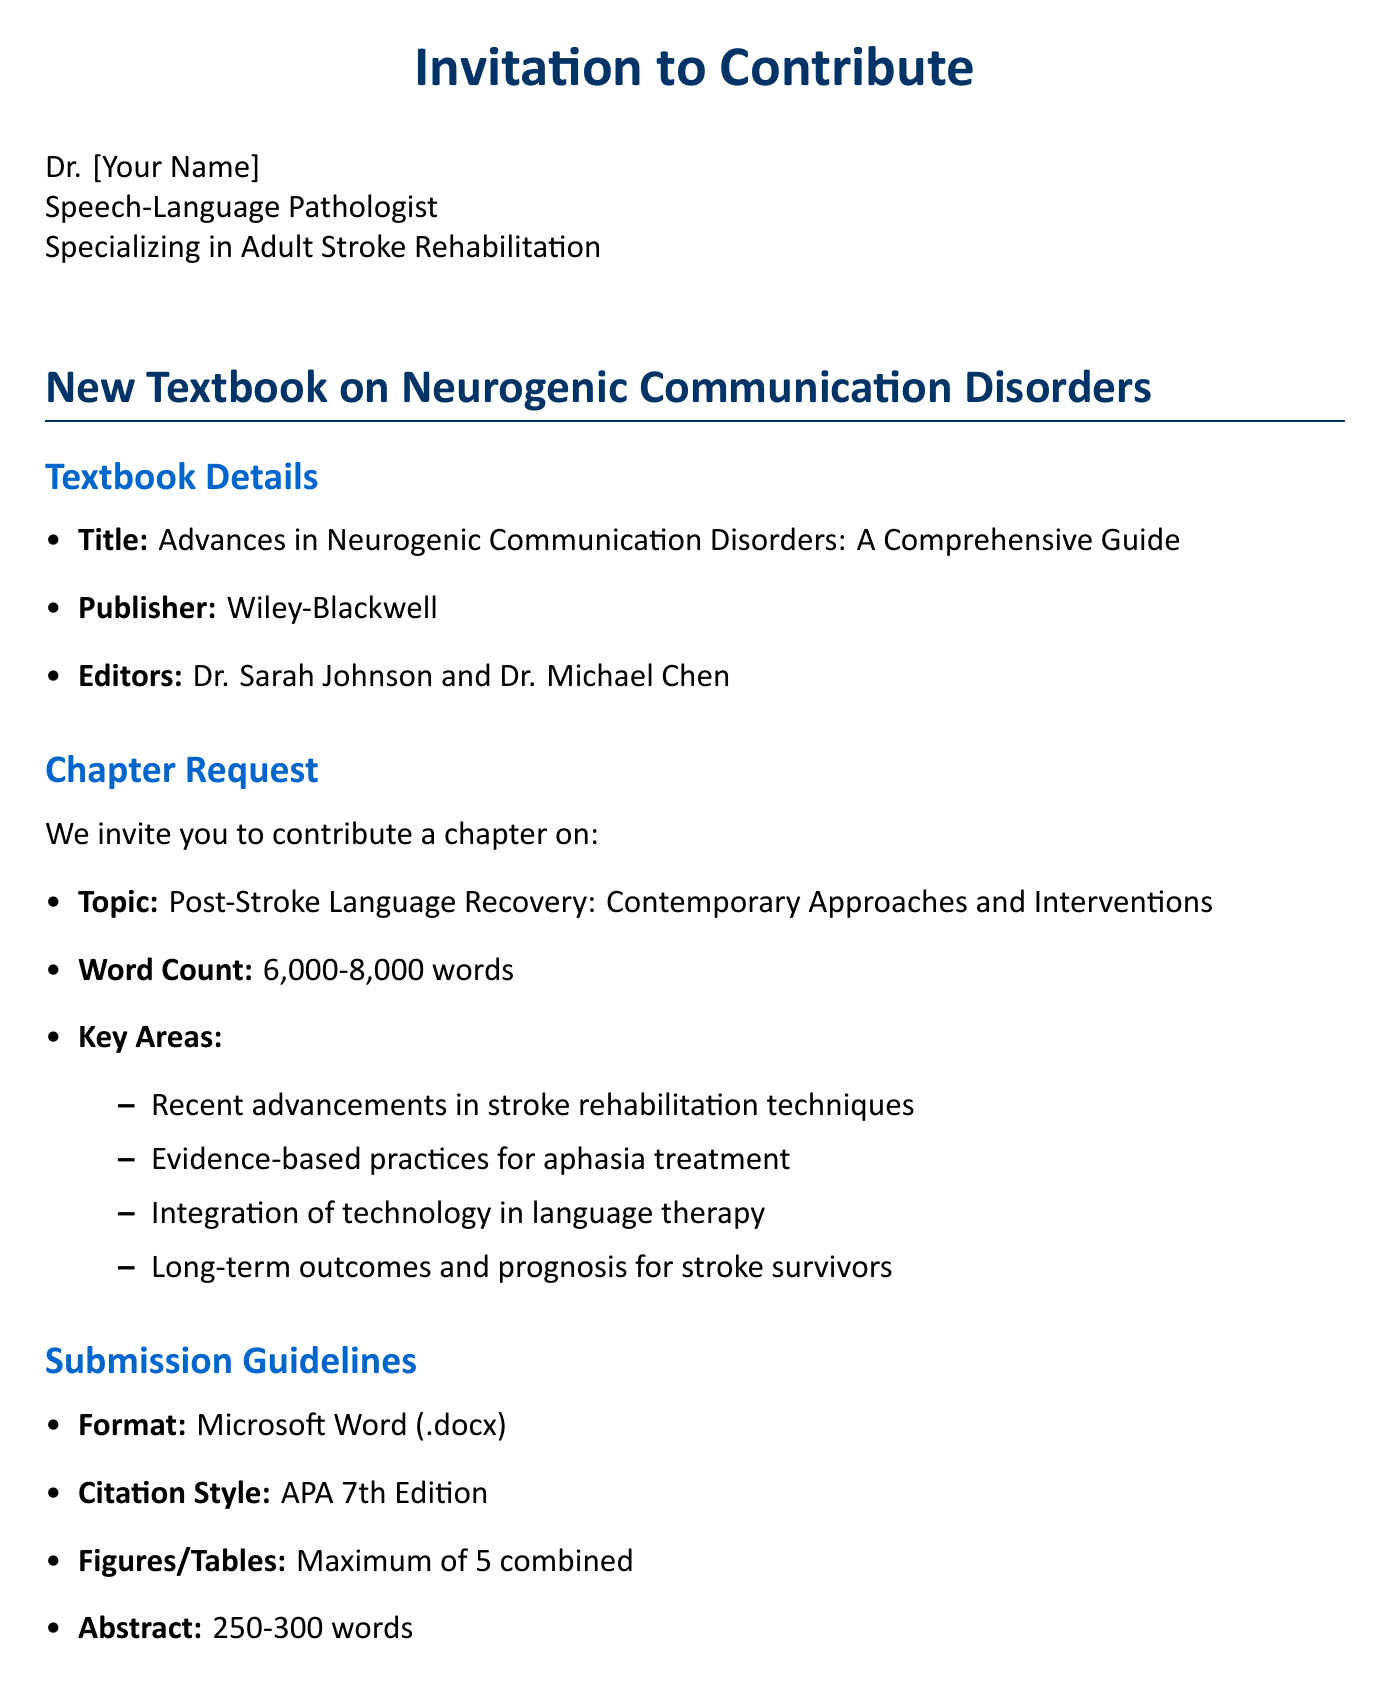What is the title of the textbook? The title of the textbook is provided in the document.
Answer: Advances in Neurogenic Communication Disorders: A Comprehensive Guide Who are the editors of the textbook? The document lists the editors of the textbook as part of the details section.
Answer: Dr. Sarah Johnson and Dr. Michael Chen What is the word count range for the chapter? The document specifies the required word count for the chapter in the chapter request section.
Answer: 6,000-8,000 words When is the abstract submission deadline? The abstract submission deadline is listed under important dates in the document.
Answer: September 15, 2023 What is one of the key areas to be covered in the chapter? The document outlines several key areas under chapter request that need to be addressed in the chapter.
Answer: Recent advancements in stroke rehabilitation techniques What format should the manuscript be submitted in? The submission guidelines section of the document specifies the required format for the manuscript.
Answer: Microsoft Word (.docx) When is the final manuscript due? The final manuscript due date is indicated in the important dates section of the document.
Answer: June 30, 2024 What citation style should be used in the manuscript? The document provides specific submission guidelines regarding citation style in the submission guidelines section.
Answer: APA 7th Edition What is the email contact for inquiries? The contact information section of the document lists the email for further inquiries.
Answer: neurogenic.disorders@wiley.com 